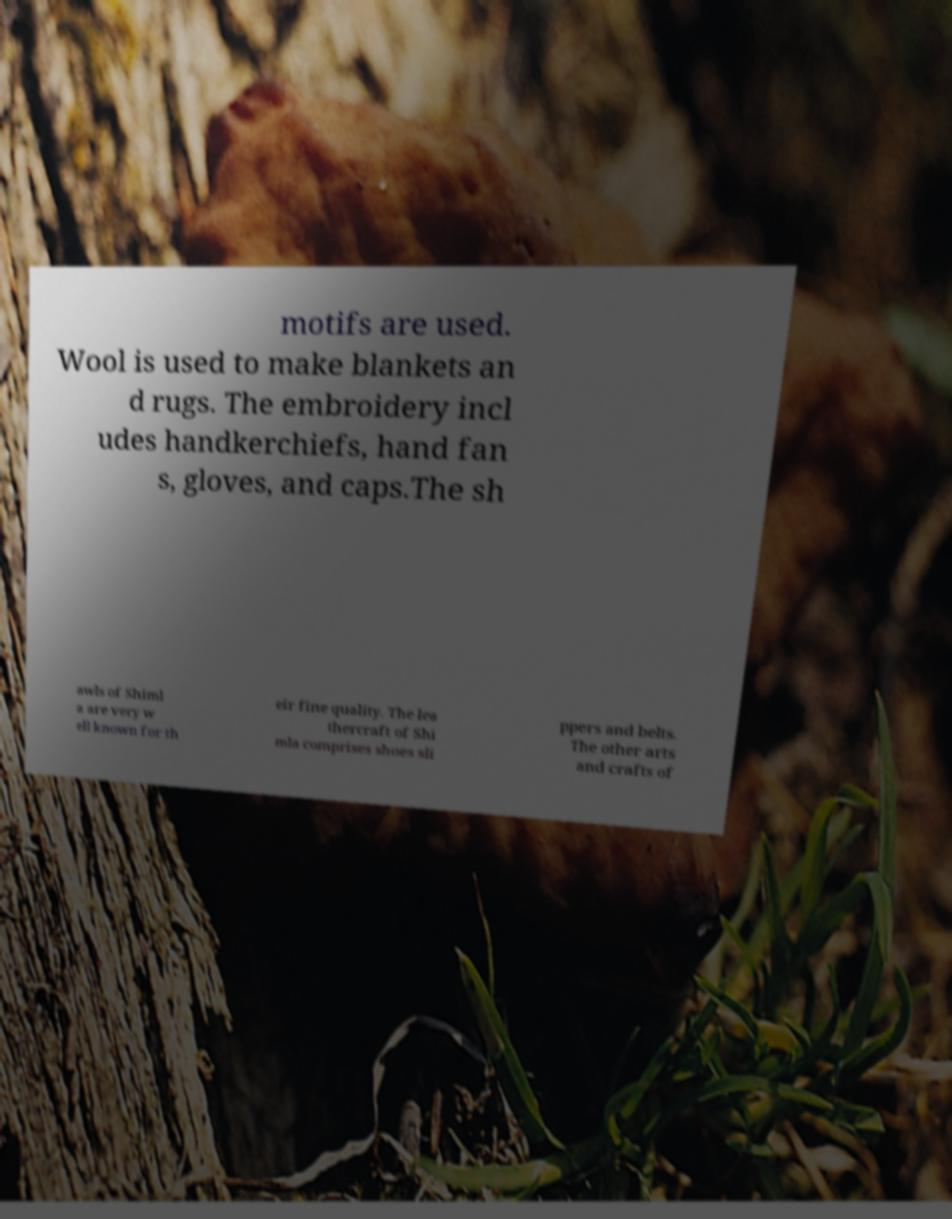What messages or text are displayed in this image? I need them in a readable, typed format. motifs are used. Wool is used to make blankets an d rugs. The embroidery incl udes handkerchiefs, hand fan s, gloves, and caps.The sh awls of Shiml a are very w ell known for th eir fine quality. The lea thercraft of Shi mla comprises shoes sli ppers and belts. The other arts and crafts of 